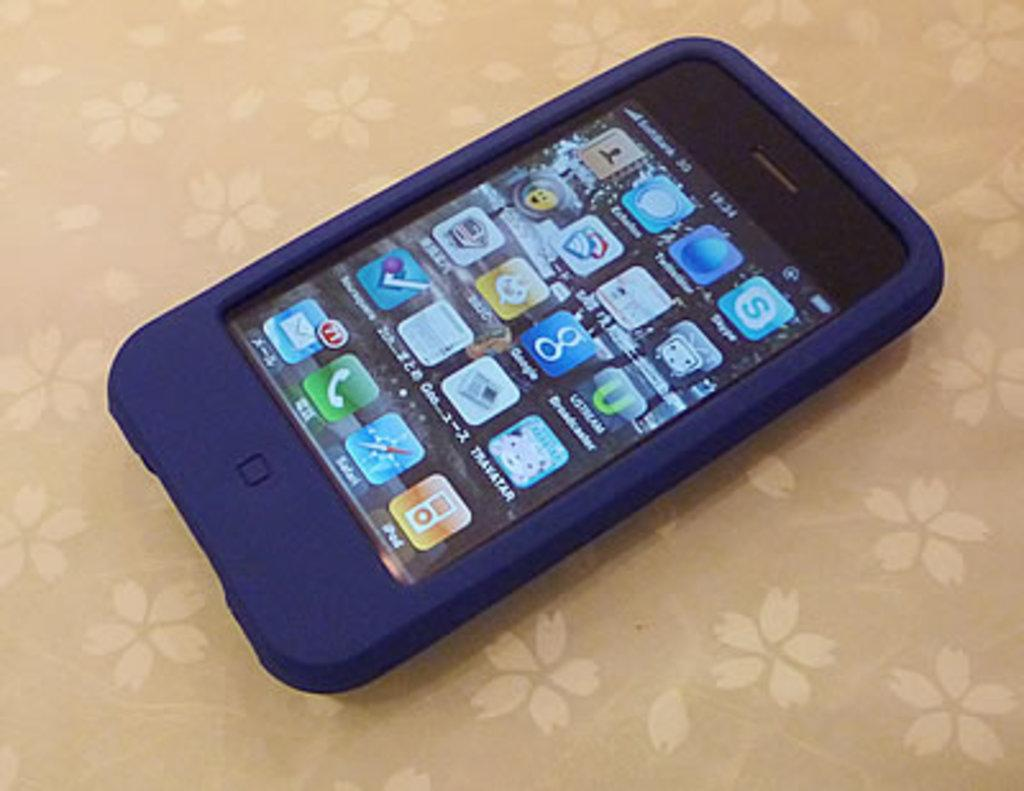What is the main subject of the image? The main subject of the image is a mobile phone. What is located at the bottom of the image? There is a cloth at the bottom of the image. What type of teeth can be seen in the image? There are no teeth present in the image. What kind of creature is visible in the image? There is no creature visible in the image. 